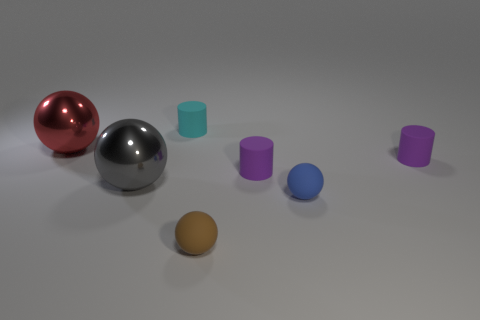Does the red thing have the same material as the gray sphere behind the blue thing?
Ensure brevity in your answer.  Yes. How many spheres are both left of the big gray thing and in front of the small blue ball?
Offer a very short reply. 0. What shape is the brown thing that is the same size as the blue sphere?
Your answer should be very brief. Sphere. There is a metallic thing in front of the tiny purple matte cylinder right of the blue ball; is there a object on the left side of it?
Ensure brevity in your answer.  Yes. What is the size of the metal ball behind the big thing that is in front of the red ball?
Provide a succinct answer. Large. What number of objects are either small objects left of the brown thing or gray blocks?
Your answer should be compact. 1. Is there a blue shiny sphere that has the same size as the brown thing?
Your response must be concise. No. Is there a big gray metal object on the left side of the metal sphere that is to the right of the large red metal object?
Provide a short and direct response. No. What number of balls are either big brown metallic objects or cyan rubber things?
Give a very brief answer. 0. Are there any big yellow objects that have the same shape as the cyan object?
Make the answer very short. No. 